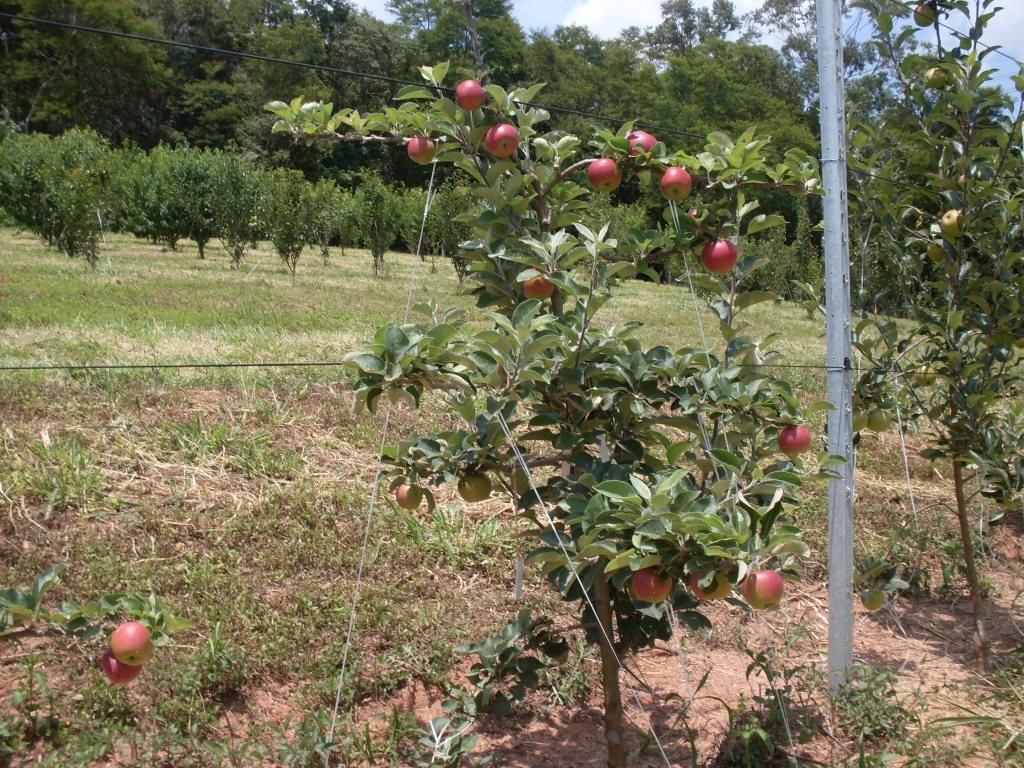What type of vegetation can be seen in the image? There are trees in the image. What is growing on the trees? Apples are present on the trees. What is the ground covered with in the image? There is grass on the ground. How would you describe the sky in the image? The sky is blue and cloudy. Where is the nearest store to purchase apples in the image? There is no store present in the image, and the location of a store cannot be determined from the image. 